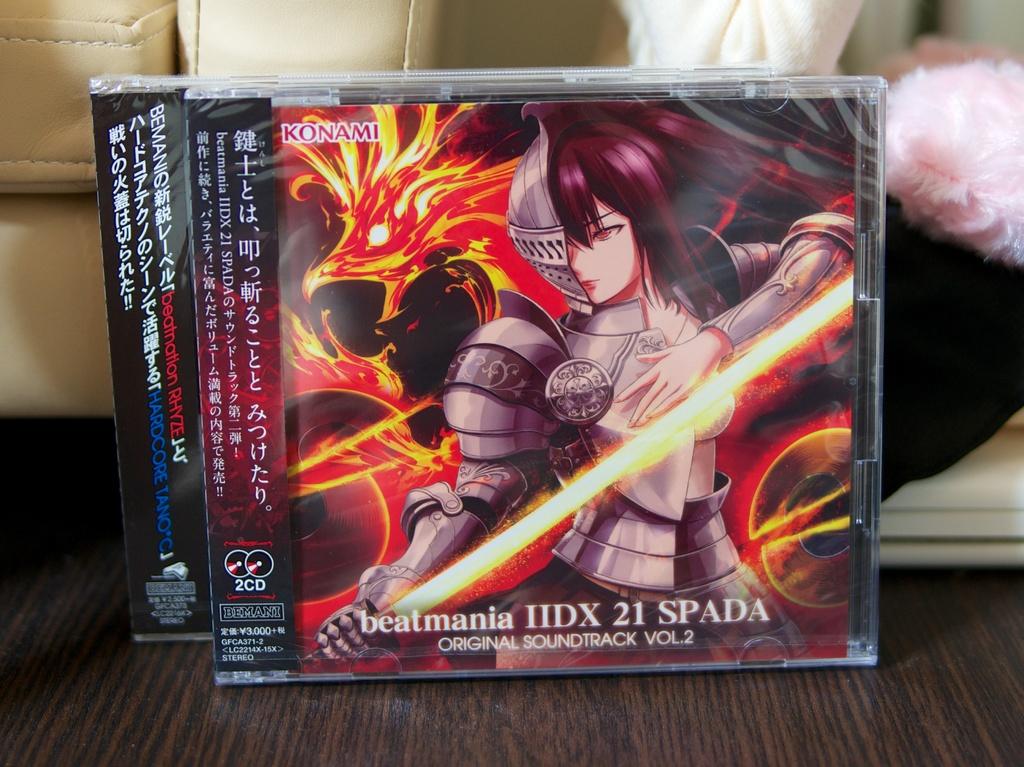What volume is this soundtrack?
Offer a terse response. 2. What is the title of this soundtrack?
Your answer should be compact. Beatmania. 